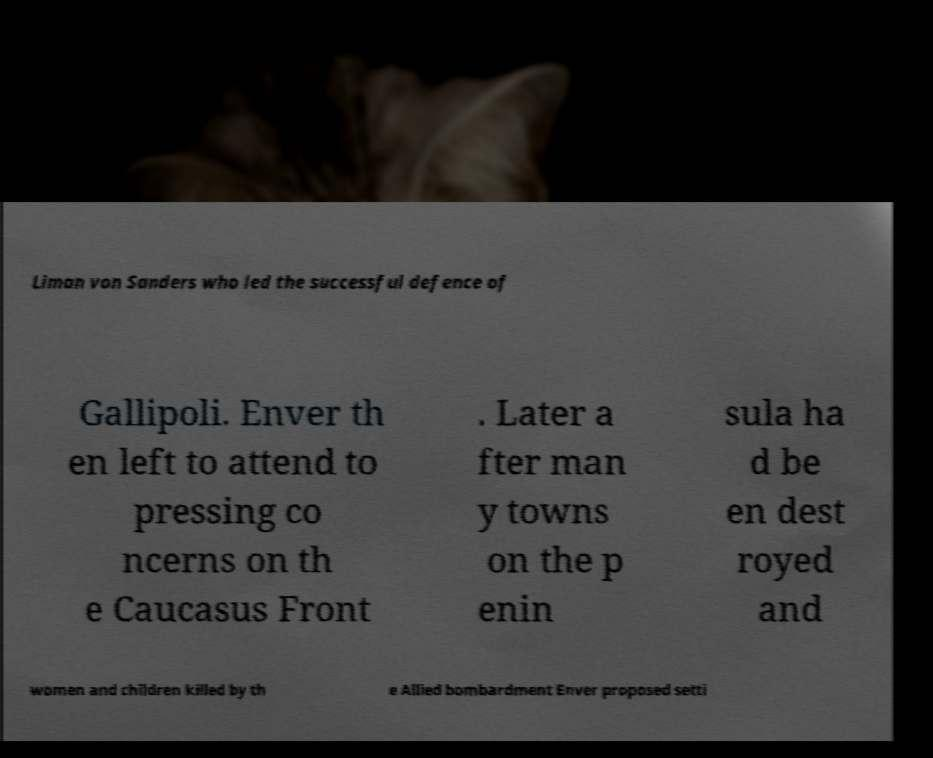I need the written content from this picture converted into text. Can you do that? Liman von Sanders who led the successful defence of Gallipoli. Enver th en left to attend to pressing co ncerns on th e Caucasus Front . Later a fter man y towns on the p enin sula ha d be en dest royed and women and children killed by th e Allied bombardment Enver proposed setti 